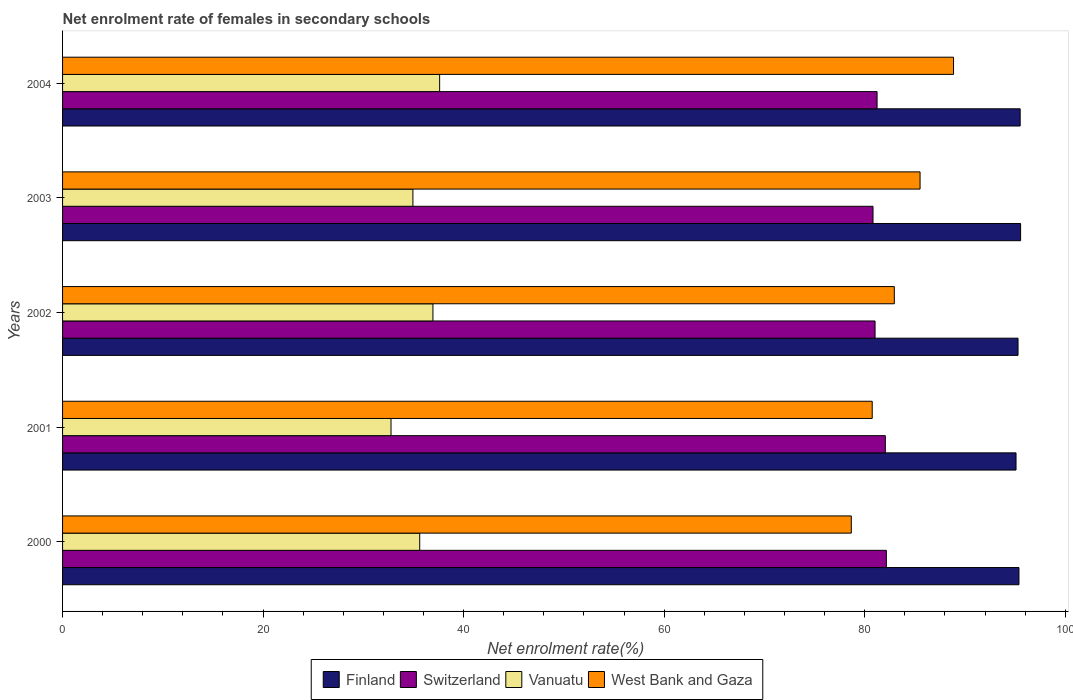How many groups of bars are there?
Keep it short and to the point. 5. How many bars are there on the 5th tick from the top?
Ensure brevity in your answer.  4. How many bars are there on the 3rd tick from the bottom?
Your answer should be compact. 4. What is the net enrolment rate of females in secondary schools in Switzerland in 2001?
Provide a short and direct response. 82.06. Across all years, what is the maximum net enrolment rate of females in secondary schools in Vanuatu?
Give a very brief answer. 37.61. Across all years, what is the minimum net enrolment rate of females in secondary schools in Vanuatu?
Your answer should be compact. 32.76. In which year was the net enrolment rate of females in secondary schools in Vanuatu minimum?
Your answer should be very brief. 2001. What is the total net enrolment rate of females in secondary schools in West Bank and Gaza in the graph?
Keep it short and to the point. 416.75. What is the difference between the net enrolment rate of females in secondary schools in Switzerland in 2002 and that in 2003?
Provide a short and direct response. 0.2. What is the difference between the net enrolment rate of females in secondary schools in West Bank and Gaza in 2004 and the net enrolment rate of females in secondary schools in Vanuatu in 2002?
Your response must be concise. 51.92. What is the average net enrolment rate of females in secondary schools in Finland per year?
Keep it short and to the point. 95.37. In the year 2002, what is the difference between the net enrolment rate of females in secondary schools in Finland and net enrolment rate of females in secondary schools in Vanuatu?
Make the answer very short. 58.35. What is the ratio of the net enrolment rate of females in secondary schools in Finland in 2001 to that in 2003?
Give a very brief answer. 1. Is the difference between the net enrolment rate of females in secondary schools in Finland in 2001 and 2004 greater than the difference between the net enrolment rate of females in secondary schools in Vanuatu in 2001 and 2004?
Offer a very short reply. Yes. What is the difference between the highest and the second highest net enrolment rate of females in secondary schools in West Bank and Gaza?
Offer a very short reply. 3.34. What is the difference between the highest and the lowest net enrolment rate of females in secondary schools in Vanuatu?
Keep it short and to the point. 4.85. Is the sum of the net enrolment rate of females in secondary schools in Finland in 2001 and 2002 greater than the maximum net enrolment rate of females in secondary schools in Switzerland across all years?
Ensure brevity in your answer.  Yes. Is it the case that in every year, the sum of the net enrolment rate of females in secondary schools in Vanuatu and net enrolment rate of females in secondary schools in Finland is greater than the sum of net enrolment rate of females in secondary schools in Switzerland and net enrolment rate of females in secondary schools in West Bank and Gaza?
Offer a terse response. Yes. What does the 3rd bar from the top in 2003 represents?
Your answer should be very brief. Switzerland. What does the 3rd bar from the bottom in 2004 represents?
Your answer should be very brief. Vanuatu. How many bars are there?
Keep it short and to the point. 20. Are all the bars in the graph horizontal?
Make the answer very short. Yes. What is the difference between two consecutive major ticks on the X-axis?
Your answer should be very brief. 20. Does the graph contain any zero values?
Keep it short and to the point. No. Does the graph contain grids?
Keep it short and to the point. No. How many legend labels are there?
Your response must be concise. 4. What is the title of the graph?
Your answer should be compact. Net enrolment rate of females in secondary schools. Does "Low income" appear as one of the legend labels in the graph?
Ensure brevity in your answer.  No. What is the label or title of the X-axis?
Ensure brevity in your answer.  Net enrolment rate(%). What is the Net enrolment rate(%) of Finland in 2000?
Make the answer very short. 95.39. What is the Net enrolment rate(%) of Switzerland in 2000?
Your response must be concise. 82.16. What is the Net enrolment rate(%) of Vanuatu in 2000?
Provide a succinct answer. 35.62. What is the Net enrolment rate(%) in West Bank and Gaza in 2000?
Your response must be concise. 78.66. What is the Net enrolment rate(%) in Finland in 2001?
Ensure brevity in your answer.  95.09. What is the Net enrolment rate(%) of Switzerland in 2001?
Ensure brevity in your answer.  82.06. What is the Net enrolment rate(%) in Vanuatu in 2001?
Offer a very short reply. 32.76. What is the Net enrolment rate(%) of West Bank and Gaza in 2001?
Provide a succinct answer. 80.75. What is the Net enrolment rate(%) of Finland in 2002?
Give a very brief answer. 95.29. What is the Net enrolment rate(%) in Switzerland in 2002?
Your answer should be very brief. 81.03. What is the Net enrolment rate(%) in Vanuatu in 2002?
Offer a very short reply. 36.94. What is the Net enrolment rate(%) in West Bank and Gaza in 2002?
Your answer should be compact. 82.95. What is the Net enrolment rate(%) in Finland in 2003?
Ensure brevity in your answer.  95.55. What is the Net enrolment rate(%) of Switzerland in 2003?
Keep it short and to the point. 80.83. What is the Net enrolment rate(%) of Vanuatu in 2003?
Your answer should be very brief. 34.94. What is the Net enrolment rate(%) of West Bank and Gaza in 2003?
Make the answer very short. 85.52. What is the Net enrolment rate(%) in Finland in 2004?
Your answer should be compact. 95.51. What is the Net enrolment rate(%) of Switzerland in 2004?
Give a very brief answer. 81.24. What is the Net enrolment rate(%) in Vanuatu in 2004?
Keep it short and to the point. 37.61. What is the Net enrolment rate(%) in West Bank and Gaza in 2004?
Offer a terse response. 88.86. Across all years, what is the maximum Net enrolment rate(%) of Finland?
Offer a very short reply. 95.55. Across all years, what is the maximum Net enrolment rate(%) of Switzerland?
Provide a short and direct response. 82.16. Across all years, what is the maximum Net enrolment rate(%) in Vanuatu?
Your answer should be very brief. 37.61. Across all years, what is the maximum Net enrolment rate(%) in West Bank and Gaza?
Provide a succinct answer. 88.86. Across all years, what is the minimum Net enrolment rate(%) in Finland?
Offer a very short reply. 95.09. Across all years, what is the minimum Net enrolment rate(%) in Switzerland?
Provide a succinct answer. 80.83. Across all years, what is the minimum Net enrolment rate(%) of Vanuatu?
Give a very brief answer. 32.76. Across all years, what is the minimum Net enrolment rate(%) in West Bank and Gaza?
Provide a succinct answer. 78.66. What is the total Net enrolment rate(%) of Finland in the graph?
Keep it short and to the point. 476.83. What is the total Net enrolment rate(%) of Switzerland in the graph?
Your answer should be very brief. 407.32. What is the total Net enrolment rate(%) in Vanuatu in the graph?
Provide a short and direct response. 177.87. What is the total Net enrolment rate(%) in West Bank and Gaza in the graph?
Offer a very short reply. 416.75. What is the difference between the Net enrolment rate(%) in Finland in 2000 and that in 2001?
Offer a terse response. 0.29. What is the difference between the Net enrolment rate(%) of Switzerland in 2000 and that in 2001?
Ensure brevity in your answer.  0.1. What is the difference between the Net enrolment rate(%) in Vanuatu in 2000 and that in 2001?
Offer a very short reply. 2.86. What is the difference between the Net enrolment rate(%) of West Bank and Gaza in 2000 and that in 2001?
Your answer should be compact. -2.09. What is the difference between the Net enrolment rate(%) of Finland in 2000 and that in 2002?
Make the answer very short. 0.09. What is the difference between the Net enrolment rate(%) of Switzerland in 2000 and that in 2002?
Your answer should be very brief. 1.13. What is the difference between the Net enrolment rate(%) of Vanuatu in 2000 and that in 2002?
Offer a very short reply. -1.32. What is the difference between the Net enrolment rate(%) of West Bank and Gaza in 2000 and that in 2002?
Keep it short and to the point. -4.29. What is the difference between the Net enrolment rate(%) in Finland in 2000 and that in 2003?
Your answer should be very brief. -0.16. What is the difference between the Net enrolment rate(%) of Switzerland in 2000 and that in 2003?
Your response must be concise. 1.33. What is the difference between the Net enrolment rate(%) of Vanuatu in 2000 and that in 2003?
Provide a succinct answer. 0.68. What is the difference between the Net enrolment rate(%) in West Bank and Gaza in 2000 and that in 2003?
Your response must be concise. -6.86. What is the difference between the Net enrolment rate(%) in Finland in 2000 and that in 2004?
Offer a terse response. -0.12. What is the difference between the Net enrolment rate(%) in Switzerland in 2000 and that in 2004?
Your answer should be compact. 0.93. What is the difference between the Net enrolment rate(%) in Vanuatu in 2000 and that in 2004?
Provide a short and direct response. -1.99. What is the difference between the Net enrolment rate(%) in West Bank and Gaza in 2000 and that in 2004?
Offer a terse response. -10.2. What is the difference between the Net enrolment rate(%) of Finland in 2001 and that in 2002?
Offer a terse response. -0.2. What is the difference between the Net enrolment rate(%) of Switzerland in 2001 and that in 2002?
Your response must be concise. 1.02. What is the difference between the Net enrolment rate(%) of Vanuatu in 2001 and that in 2002?
Offer a very short reply. -4.18. What is the difference between the Net enrolment rate(%) of West Bank and Gaza in 2001 and that in 2002?
Provide a short and direct response. -2.2. What is the difference between the Net enrolment rate(%) of Finland in 2001 and that in 2003?
Keep it short and to the point. -0.46. What is the difference between the Net enrolment rate(%) in Switzerland in 2001 and that in 2003?
Give a very brief answer. 1.23. What is the difference between the Net enrolment rate(%) of Vanuatu in 2001 and that in 2003?
Your answer should be very brief. -2.18. What is the difference between the Net enrolment rate(%) of West Bank and Gaza in 2001 and that in 2003?
Your answer should be compact. -4.77. What is the difference between the Net enrolment rate(%) in Finland in 2001 and that in 2004?
Offer a terse response. -0.41. What is the difference between the Net enrolment rate(%) of Switzerland in 2001 and that in 2004?
Provide a short and direct response. 0.82. What is the difference between the Net enrolment rate(%) in Vanuatu in 2001 and that in 2004?
Ensure brevity in your answer.  -4.85. What is the difference between the Net enrolment rate(%) of West Bank and Gaza in 2001 and that in 2004?
Provide a succinct answer. -8.11. What is the difference between the Net enrolment rate(%) in Finland in 2002 and that in 2003?
Ensure brevity in your answer.  -0.26. What is the difference between the Net enrolment rate(%) of Switzerland in 2002 and that in 2003?
Your response must be concise. 0.2. What is the difference between the Net enrolment rate(%) in Vanuatu in 2002 and that in 2003?
Your answer should be very brief. 2. What is the difference between the Net enrolment rate(%) in West Bank and Gaza in 2002 and that in 2003?
Offer a terse response. -2.57. What is the difference between the Net enrolment rate(%) in Finland in 2002 and that in 2004?
Provide a short and direct response. -0.21. What is the difference between the Net enrolment rate(%) of Switzerland in 2002 and that in 2004?
Ensure brevity in your answer.  -0.2. What is the difference between the Net enrolment rate(%) in Vanuatu in 2002 and that in 2004?
Provide a succinct answer. -0.67. What is the difference between the Net enrolment rate(%) of West Bank and Gaza in 2002 and that in 2004?
Your answer should be very brief. -5.91. What is the difference between the Net enrolment rate(%) in Finland in 2003 and that in 2004?
Your answer should be very brief. 0.04. What is the difference between the Net enrolment rate(%) of Switzerland in 2003 and that in 2004?
Ensure brevity in your answer.  -0.41. What is the difference between the Net enrolment rate(%) in Vanuatu in 2003 and that in 2004?
Your answer should be compact. -2.67. What is the difference between the Net enrolment rate(%) of West Bank and Gaza in 2003 and that in 2004?
Keep it short and to the point. -3.34. What is the difference between the Net enrolment rate(%) in Finland in 2000 and the Net enrolment rate(%) in Switzerland in 2001?
Ensure brevity in your answer.  13.33. What is the difference between the Net enrolment rate(%) of Finland in 2000 and the Net enrolment rate(%) of Vanuatu in 2001?
Your answer should be compact. 62.63. What is the difference between the Net enrolment rate(%) of Finland in 2000 and the Net enrolment rate(%) of West Bank and Gaza in 2001?
Offer a very short reply. 14.64. What is the difference between the Net enrolment rate(%) in Switzerland in 2000 and the Net enrolment rate(%) in Vanuatu in 2001?
Give a very brief answer. 49.4. What is the difference between the Net enrolment rate(%) of Switzerland in 2000 and the Net enrolment rate(%) of West Bank and Gaza in 2001?
Provide a short and direct response. 1.41. What is the difference between the Net enrolment rate(%) in Vanuatu in 2000 and the Net enrolment rate(%) in West Bank and Gaza in 2001?
Make the answer very short. -45.13. What is the difference between the Net enrolment rate(%) of Finland in 2000 and the Net enrolment rate(%) of Switzerland in 2002?
Make the answer very short. 14.35. What is the difference between the Net enrolment rate(%) in Finland in 2000 and the Net enrolment rate(%) in Vanuatu in 2002?
Your answer should be compact. 58.45. What is the difference between the Net enrolment rate(%) in Finland in 2000 and the Net enrolment rate(%) in West Bank and Gaza in 2002?
Keep it short and to the point. 12.43. What is the difference between the Net enrolment rate(%) in Switzerland in 2000 and the Net enrolment rate(%) in Vanuatu in 2002?
Ensure brevity in your answer.  45.22. What is the difference between the Net enrolment rate(%) of Switzerland in 2000 and the Net enrolment rate(%) of West Bank and Gaza in 2002?
Keep it short and to the point. -0.79. What is the difference between the Net enrolment rate(%) of Vanuatu in 2000 and the Net enrolment rate(%) of West Bank and Gaza in 2002?
Keep it short and to the point. -47.33. What is the difference between the Net enrolment rate(%) in Finland in 2000 and the Net enrolment rate(%) in Switzerland in 2003?
Offer a very short reply. 14.56. What is the difference between the Net enrolment rate(%) in Finland in 2000 and the Net enrolment rate(%) in Vanuatu in 2003?
Make the answer very short. 60.45. What is the difference between the Net enrolment rate(%) in Finland in 2000 and the Net enrolment rate(%) in West Bank and Gaza in 2003?
Your answer should be very brief. 9.86. What is the difference between the Net enrolment rate(%) of Switzerland in 2000 and the Net enrolment rate(%) of Vanuatu in 2003?
Your answer should be very brief. 47.22. What is the difference between the Net enrolment rate(%) of Switzerland in 2000 and the Net enrolment rate(%) of West Bank and Gaza in 2003?
Offer a terse response. -3.36. What is the difference between the Net enrolment rate(%) of Vanuatu in 2000 and the Net enrolment rate(%) of West Bank and Gaza in 2003?
Offer a terse response. -49.9. What is the difference between the Net enrolment rate(%) of Finland in 2000 and the Net enrolment rate(%) of Switzerland in 2004?
Ensure brevity in your answer.  14.15. What is the difference between the Net enrolment rate(%) of Finland in 2000 and the Net enrolment rate(%) of Vanuatu in 2004?
Offer a very short reply. 57.78. What is the difference between the Net enrolment rate(%) in Finland in 2000 and the Net enrolment rate(%) in West Bank and Gaza in 2004?
Keep it short and to the point. 6.53. What is the difference between the Net enrolment rate(%) in Switzerland in 2000 and the Net enrolment rate(%) in Vanuatu in 2004?
Keep it short and to the point. 44.55. What is the difference between the Net enrolment rate(%) of Switzerland in 2000 and the Net enrolment rate(%) of West Bank and Gaza in 2004?
Keep it short and to the point. -6.7. What is the difference between the Net enrolment rate(%) in Vanuatu in 2000 and the Net enrolment rate(%) in West Bank and Gaza in 2004?
Ensure brevity in your answer.  -53.24. What is the difference between the Net enrolment rate(%) in Finland in 2001 and the Net enrolment rate(%) in Switzerland in 2002?
Ensure brevity in your answer.  14.06. What is the difference between the Net enrolment rate(%) in Finland in 2001 and the Net enrolment rate(%) in Vanuatu in 2002?
Offer a terse response. 58.15. What is the difference between the Net enrolment rate(%) of Finland in 2001 and the Net enrolment rate(%) of West Bank and Gaza in 2002?
Provide a short and direct response. 12.14. What is the difference between the Net enrolment rate(%) in Switzerland in 2001 and the Net enrolment rate(%) in Vanuatu in 2002?
Offer a terse response. 45.12. What is the difference between the Net enrolment rate(%) of Switzerland in 2001 and the Net enrolment rate(%) of West Bank and Gaza in 2002?
Offer a terse response. -0.89. What is the difference between the Net enrolment rate(%) of Vanuatu in 2001 and the Net enrolment rate(%) of West Bank and Gaza in 2002?
Provide a short and direct response. -50.2. What is the difference between the Net enrolment rate(%) in Finland in 2001 and the Net enrolment rate(%) in Switzerland in 2003?
Give a very brief answer. 14.26. What is the difference between the Net enrolment rate(%) of Finland in 2001 and the Net enrolment rate(%) of Vanuatu in 2003?
Give a very brief answer. 60.15. What is the difference between the Net enrolment rate(%) of Finland in 2001 and the Net enrolment rate(%) of West Bank and Gaza in 2003?
Ensure brevity in your answer.  9.57. What is the difference between the Net enrolment rate(%) of Switzerland in 2001 and the Net enrolment rate(%) of Vanuatu in 2003?
Offer a terse response. 47.12. What is the difference between the Net enrolment rate(%) in Switzerland in 2001 and the Net enrolment rate(%) in West Bank and Gaza in 2003?
Give a very brief answer. -3.46. What is the difference between the Net enrolment rate(%) of Vanuatu in 2001 and the Net enrolment rate(%) of West Bank and Gaza in 2003?
Give a very brief answer. -52.76. What is the difference between the Net enrolment rate(%) of Finland in 2001 and the Net enrolment rate(%) of Switzerland in 2004?
Offer a very short reply. 13.86. What is the difference between the Net enrolment rate(%) of Finland in 2001 and the Net enrolment rate(%) of Vanuatu in 2004?
Offer a very short reply. 57.48. What is the difference between the Net enrolment rate(%) of Finland in 2001 and the Net enrolment rate(%) of West Bank and Gaza in 2004?
Make the answer very short. 6.23. What is the difference between the Net enrolment rate(%) of Switzerland in 2001 and the Net enrolment rate(%) of Vanuatu in 2004?
Your answer should be compact. 44.45. What is the difference between the Net enrolment rate(%) of Switzerland in 2001 and the Net enrolment rate(%) of West Bank and Gaza in 2004?
Ensure brevity in your answer.  -6.8. What is the difference between the Net enrolment rate(%) in Vanuatu in 2001 and the Net enrolment rate(%) in West Bank and Gaza in 2004?
Ensure brevity in your answer.  -56.1. What is the difference between the Net enrolment rate(%) of Finland in 2002 and the Net enrolment rate(%) of Switzerland in 2003?
Your response must be concise. 14.46. What is the difference between the Net enrolment rate(%) in Finland in 2002 and the Net enrolment rate(%) in Vanuatu in 2003?
Ensure brevity in your answer.  60.35. What is the difference between the Net enrolment rate(%) of Finland in 2002 and the Net enrolment rate(%) of West Bank and Gaza in 2003?
Provide a short and direct response. 9.77. What is the difference between the Net enrolment rate(%) in Switzerland in 2002 and the Net enrolment rate(%) in Vanuatu in 2003?
Ensure brevity in your answer.  46.09. What is the difference between the Net enrolment rate(%) of Switzerland in 2002 and the Net enrolment rate(%) of West Bank and Gaza in 2003?
Offer a very short reply. -4.49. What is the difference between the Net enrolment rate(%) in Vanuatu in 2002 and the Net enrolment rate(%) in West Bank and Gaza in 2003?
Your answer should be very brief. -48.58. What is the difference between the Net enrolment rate(%) of Finland in 2002 and the Net enrolment rate(%) of Switzerland in 2004?
Keep it short and to the point. 14.06. What is the difference between the Net enrolment rate(%) in Finland in 2002 and the Net enrolment rate(%) in Vanuatu in 2004?
Your response must be concise. 57.69. What is the difference between the Net enrolment rate(%) of Finland in 2002 and the Net enrolment rate(%) of West Bank and Gaza in 2004?
Give a very brief answer. 6.43. What is the difference between the Net enrolment rate(%) of Switzerland in 2002 and the Net enrolment rate(%) of Vanuatu in 2004?
Your response must be concise. 43.43. What is the difference between the Net enrolment rate(%) of Switzerland in 2002 and the Net enrolment rate(%) of West Bank and Gaza in 2004?
Your answer should be compact. -7.83. What is the difference between the Net enrolment rate(%) of Vanuatu in 2002 and the Net enrolment rate(%) of West Bank and Gaza in 2004?
Provide a short and direct response. -51.92. What is the difference between the Net enrolment rate(%) of Finland in 2003 and the Net enrolment rate(%) of Switzerland in 2004?
Your answer should be very brief. 14.31. What is the difference between the Net enrolment rate(%) in Finland in 2003 and the Net enrolment rate(%) in Vanuatu in 2004?
Your answer should be compact. 57.94. What is the difference between the Net enrolment rate(%) in Finland in 2003 and the Net enrolment rate(%) in West Bank and Gaza in 2004?
Offer a terse response. 6.69. What is the difference between the Net enrolment rate(%) in Switzerland in 2003 and the Net enrolment rate(%) in Vanuatu in 2004?
Provide a short and direct response. 43.22. What is the difference between the Net enrolment rate(%) in Switzerland in 2003 and the Net enrolment rate(%) in West Bank and Gaza in 2004?
Offer a terse response. -8.03. What is the difference between the Net enrolment rate(%) of Vanuatu in 2003 and the Net enrolment rate(%) of West Bank and Gaza in 2004?
Provide a succinct answer. -53.92. What is the average Net enrolment rate(%) of Finland per year?
Offer a very short reply. 95.37. What is the average Net enrolment rate(%) of Switzerland per year?
Provide a short and direct response. 81.46. What is the average Net enrolment rate(%) of Vanuatu per year?
Your answer should be compact. 35.57. What is the average Net enrolment rate(%) of West Bank and Gaza per year?
Keep it short and to the point. 83.35. In the year 2000, what is the difference between the Net enrolment rate(%) of Finland and Net enrolment rate(%) of Switzerland?
Provide a succinct answer. 13.22. In the year 2000, what is the difference between the Net enrolment rate(%) of Finland and Net enrolment rate(%) of Vanuatu?
Your answer should be very brief. 59.77. In the year 2000, what is the difference between the Net enrolment rate(%) in Finland and Net enrolment rate(%) in West Bank and Gaza?
Keep it short and to the point. 16.72. In the year 2000, what is the difference between the Net enrolment rate(%) of Switzerland and Net enrolment rate(%) of Vanuatu?
Make the answer very short. 46.54. In the year 2000, what is the difference between the Net enrolment rate(%) in Switzerland and Net enrolment rate(%) in West Bank and Gaza?
Provide a succinct answer. 3.5. In the year 2000, what is the difference between the Net enrolment rate(%) in Vanuatu and Net enrolment rate(%) in West Bank and Gaza?
Your response must be concise. -43.04. In the year 2001, what is the difference between the Net enrolment rate(%) in Finland and Net enrolment rate(%) in Switzerland?
Ensure brevity in your answer.  13.03. In the year 2001, what is the difference between the Net enrolment rate(%) in Finland and Net enrolment rate(%) in Vanuatu?
Provide a succinct answer. 62.34. In the year 2001, what is the difference between the Net enrolment rate(%) of Finland and Net enrolment rate(%) of West Bank and Gaza?
Give a very brief answer. 14.34. In the year 2001, what is the difference between the Net enrolment rate(%) of Switzerland and Net enrolment rate(%) of Vanuatu?
Your answer should be very brief. 49.3. In the year 2001, what is the difference between the Net enrolment rate(%) of Switzerland and Net enrolment rate(%) of West Bank and Gaza?
Keep it short and to the point. 1.31. In the year 2001, what is the difference between the Net enrolment rate(%) in Vanuatu and Net enrolment rate(%) in West Bank and Gaza?
Provide a succinct answer. -47.99. In the year 2002, what is the difference between the Net enrolment rate(%) of Finland and Net enrolment rate(%) of Switzerland?
Keep it short and to the point. 14.26. In the year 2002, what is the difference between the Net enrolment rate(%) of Finland and Net enrolment rate(%) of Vanuatu?
Ensure brevity in your answer.  58.35. In the year 2002, what is the difference between the Net enrolment rate(%) of Finland and Net enrolment rate(%) of West Bank and Gaza?
Provide a short and direct response. 12.34. In the year 2002, what is the difference between the Net enrolment rate(%) in Switzerland and Net enrolment rate(%) in Vanuatu?
Provide a succinct answer. 44.1. In the year 2002, what is the difference between the Net enrolment rate(%) in Switzerland and Net enrolment rate(%) in West Bank and Gaza?
Offer a terse response. -1.92. In the year 2002, what is the difference between the Net enrolment rate(%) in Vanuatu and Net enrolment rate(%) in West Bank and Gaza?
Ensure brevity in your answer.  -46.01. In the year 2003, what is the difference between the Net enrolment rate(%) in Finland and Net enrolment rate(%) in Switzerland?
Your answer should be compact. 14.72. In the year 2003, what is the difference between the Net enrolment rate(%) of Finland and Net enrolment rate(%) of Vanuatu?
Make the answer very short. 60.61. In the year 2003, what is the difference between the Net enrolment rate(%) of Finland and Net enrolment rate(%) of West Bank and Gaza?
Give a very brief answer. 10.03. In the year 2003, what is the difference between the Net enrolment rate(%) of Switzerland and Net enrolment rate(%) of Vanuatu?
Ensure brevity in your answer.  45.89. In the year 2003, what is the difference between the Net enrolment rate(%) of Switzerland and Net enrolment rate(%) of West Bank and Gaza?
Your response must be concise. -4.69. In the year 2003, what is the difference between the Net enrolment rate(%) in Vanuatu and Net enrolment rate(%) in West Bank and Gaza?
Provide a short and direct response. -50.58. In the year 2004, what is the difference between the Net enrolment rate(%) of Finland and Net enrolment rate(%) of Switzerland?
Give a very brief answer. 14.27. In the year 2004, what is the difference between the Net enrolment rate(%) of Finland and Net enrolment rate(%) of Vanuatu?
Your answer should be very brief. 57.9. In the year 2004, what is the difference between the Net enrolment rate(%) in Finland and Net enrolment rate(%) in West Bank and Gaza?
Make the answer very short. 6.65. In the year 2004, what is the difference between the Net enrolment rate(%) in Switzerland and Net enrolment rate(%) in Vanuatu?
Provide a short and direct response. 43.63. In the year 2004, what is the difference between the Net enrolment rate(%) of Switzerland and Net enrolment rate(%) of West Bank and Gaza?
Provide a succinct answer. -7.62. In the year 2004, what is the difference between the Net enrolment rate(%) in Vanuatu and Net enrolment rate(%) in West Bank and Gaza?
Provide a short and direct response. -51.25. What is the ratio of the Net enrolment rate(%) of Switzerland in 2000 to that in 2001?
Ensure brevity in your answer.  1. What is the ratio of the Net enrolment rate(%) of Vanuatu in 2000 to that in 2001?
Offer a very short reply. 1.09. What is the ratio of the Net enrolment rate(%) in West Bank and Gaza in 2000 to that in 2001?
Your response must be concise. 0.97. What is the ratio of the Net enrolment rate(%) in Finland in 2000 to that in 2002?
Your answer should be very brief. 1. What is the ratio of the Net enrolment rate(%) of Switzerland in 2000 to that in 2002?
Ensure brevity in your answer.  1.01. What is the ratio of the Net enrolment rate(%) in West Bank and Gaza in 2000 to that in 2002?
Your answer should be very brief. 0.95. What is the ratio of the Net enrolment rate(%) in Finland in 2000 to that in 2003?
Keep it short and to the point. 1. What is the ratio of the Net enrolment rate(%) in Switzerland in 2000 to that in 2003?
Offer a terse response. 1.02. What is the ratio of the Net enrolment rate(%) of Vanuatu in 2000 to that in 2003?
Ensure brevity in your answer.  1.02. What is the ratio of the Net enrolment rate(%) of West Bank and Gaza in 2000 to that in 2003?
Provide a short and direct response. 0.92. What is the ratio of the Net enrolment rate(%) of Switzerland in 2000 to that in 2004?
Offer a terse response. 1.01. What is the ratio of the Net enrolment rate(%) in Vanuatu in 2000 to that in 2004?
Give a very brief answer. 0.95. What is the ratio of the Net enrolment rate(%) of West Bank and Gaza in 2000 to that in 2004?
Your answer should be compact. 0.89. What is the ratio of the Net enrolment rate(%) of Finland in 2001 to that in 2002?
Make the answer very short. 1. What is the ratio of the Net enrolment rate(%) of Switzerland in 2001 to that in 2002?
Your answer should be very brief. 1.01. What is the ratio of the Net enrolment rate(%) in Vanuatu in 2001 to that in 2002?
Give a very brief answer. 0.89. What is the ratio of the Net enrolment rate(%) of West Bank and Gaza in 2001 to that in 2002?
Give a very brief answer. 0.97. What is the ratio of the Net enrolment rate(%) of Finland in 2001 to that in 2003?
Your answer should be very brief. 1. What is the ratio of the Net enrolment rate(%) in Switzerland in 2001 to that in 2003?
Make the answer very short. 1.02. What is the ratio of the Net enrolment rate(%) in West Bank and Gaza in 2001 to that in 2003?
Provide a succinct answer. 0.94. What is the ratio of the Net enrolment rate(%) of Finland in 2001 to that in 2004?
Offer a very short reply. 1. What is the ratio of the Net enrolment rate(%) of Switzerland in 2001 to that in 2004?
Give a very brief answer. 1.01. What is the ratio of the Net enrolment rate(%) in Vanuatu in 2001 to that in 2004?
Your answer should be very brief. 0.87. What is the ratio of the Net enrolment rate(%) in West Bank and Gaza in 2001 to that in 2004?
Give a very brief answer. 0.91. What is the ratio of the Net enrolment rate(%) in Finland in 2002 to that in 2003?
Your answer should be compact. 1. What is the ratio of the Net enrolment rate(%) of Vanuatu in 2002 to that in 2003?
Provide a short and direct response. 1.06. What is the ratio of the Net enrolment rate(%) of West Bank and Gaza in 2002 to that in 2003?
Your response must be concise. 0.97. What is the ratio of the Net enrolment rate(%) of Vanuatu in 2002 to that in 2004?
Ensure brevity in your answer.  0.98. What is the ratio of the Net enrolment rate(%) in West Bank and Gaza in 2002 to that in 2004?
Keep it short and to the point. 0.93. What is the ratio of the Net enrolment rate(%) of Switzerland in 2003 to that in 2004?
Give a very brief answer. 0.99. What is the ratio of the Net enrolment rate(%) of Vanuatu in 2003 to that in 2004?
Keep it short and to the point. 0.93. What is the ratio of the Net enrolment rate(%) of West Bank and Gaza in 2003 to that in 2004?
Offer a terse response. 0.96. What is the difference between the highest and the second highest Net enrolment rate(%) in Finland?
Offer a terse response. 0.04. What is the difference between the highest and the second highest Net enrolment rate(%) of Switzerland?
Your response must be concise. 0.1. What is the difference between the highest and the second highest Net enrolment rate(%) in Vanuatu?
Offer a terse response. 0.67. What is the difference between the highest and the second highest Net enrolment rate(%) of West Bank and Gaza?
Give a very brief answer. 3.34. What is the difference between the highest and the lowest Net enrolment rate(%) in Finland?
Offer a very short reply. 0.46. What is the difference between the highest and the lowest Net enrolment rate(%) in Switzerland?
Ensure brevity in your answer.  1.33. What is the difference between the highest and the lowest Net enrolment rate(%) in Vanuatu?
Provide a succinct answer. 4.85. What is the difference between the highest and the lowest Net enrolment rate(%) in West Bank and Gaza?
Ensure brevity in your answer.  10.2. 